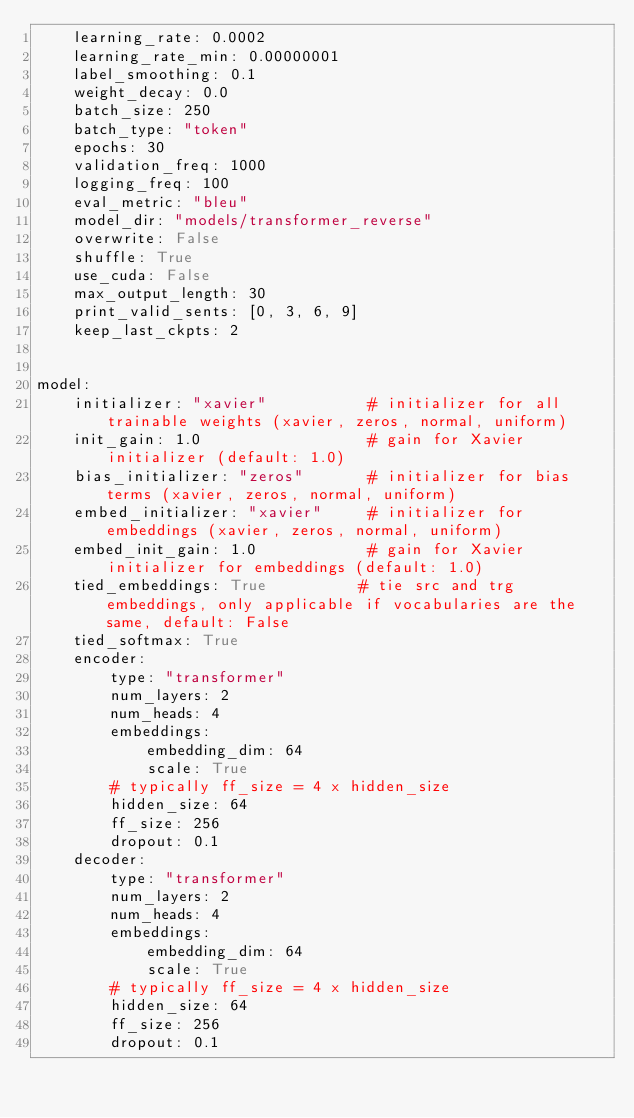Convert code to text. <code><loc_0><loc_0><loc_500><loc_500><_YAML_>    learning_rate: 0.0002
    learning_rate_min: 0.00000001
    label_smoothing: 0.1
    weight_decay: 0.0
    batch_size: 250
    batch_type: "token"
    epochs: 30
    validation_freq: 1000
    logging_freq: 100
    eval_metric: "bleu"
    model_dir: "models/transformer_reverse"
    overwrite: False
    shuffle: True
    use_cuda: False
    max_output_length: 30
    print_valid_sents: [0, 3, 6, 9]
    keep_last_ckpts: 2


model:
    initializer: "xavier"           # initializer for all trainable weights (xavier, zeros, normal, uniform)
    init_gain: 1.0                  # gain for Xavier initializer (default: 1.0)
    bias_initializer: "zeros"       # initializer for bias terms (xavier, zeros, normal, uniform)
    embed_initializer: "xavier"     # initializer for embeddings (xavier, zeros, normal, uniform)
    embed_init_gain: 1.0            # gain for Xavier initializer for embeddings (default: 1.0)
    tied_embeddings: True          # tie src and trg embeddings, only applicable if vocabularies are the same, default: False
    tied_softmax: True
    encoder:
        type: "transformer"
        num_layers: 2
        num_heads: 4
        embeddings:
            embedding_dim: 64
            scale: True
        # typically ff_size = 4 x hidden_size
        hidden_size: 64
        ff_size: 256
        dropout: 0.1
    decoder:
        type: "transformer"
        num_layers: 2
        num_heads: 4
        embeddings:
            embedding_dim: 64
            scale: True
        # typically ff_size = 4 x hidden_size
        hidden_size: 64
        ff_size: 256
        dropout: 0.1
</code> 